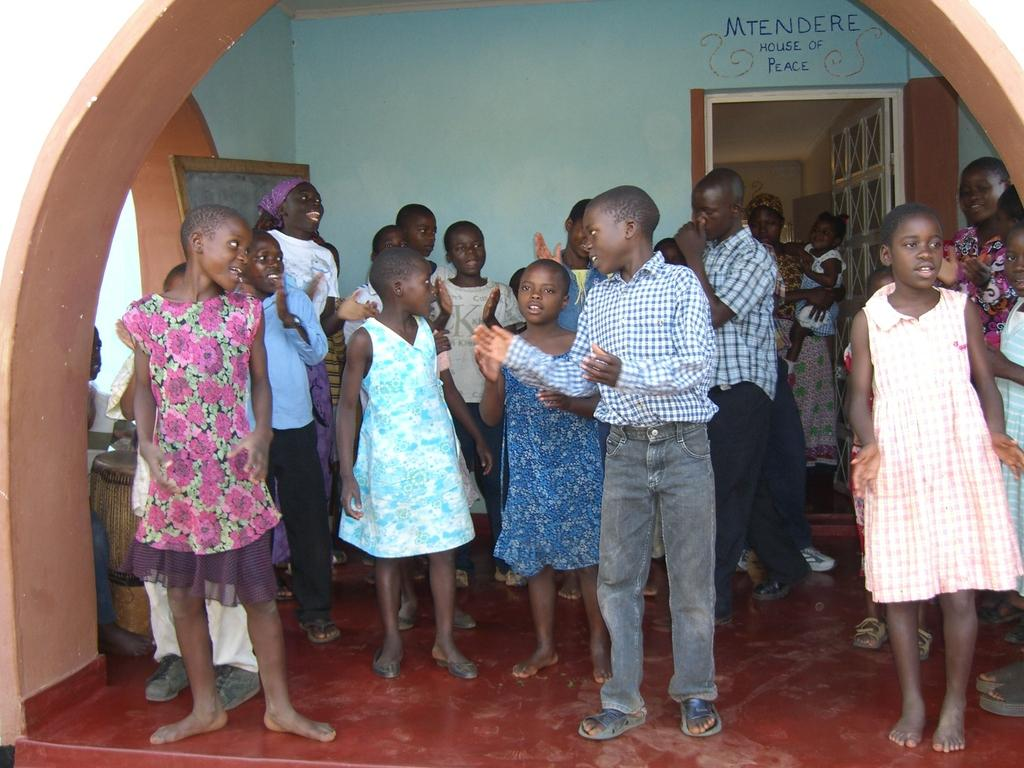What is the color of the wall in the image? The wall in the image is white. What can be seen in front of the wall? There are people standing in the image. What object is present in the image besides the wall and people? There is a board in the image. Is there any entrance or exit visible in the image? Yes, there is a door in the image. How many cherries are on the head of the person in the image? There are no cherries present in the image, nor is there any indication of a person with cherries on their head. 